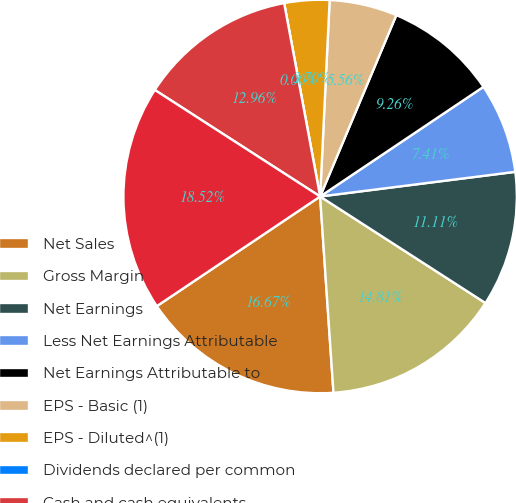Convert chart. <chart><loc_0><loc_0><loc_500><loc_500><pie_chart><fcel>Net Sales<fcel>Gross Margin<fcel>Net Earnings<fcel>Less Net Earnings Attributable<fcel>Net Earnings Attributable to<fcel>EPS - Basic (1)<fcel>EPS - Diluted^(1)<fcel>Dividends declared per common<fcel>Cash and cash equivalents<fcel>Marketable securities^(2)<nl><fcel>16.67%<fcel>14.81%<fcel>11.11%<fcel>7.41%<fcel>9.26%<fcel>5.56%<fcel>3.7%<fcel>0.0%<fcel>12.96%<fcel>18.52%<nl></chart> 